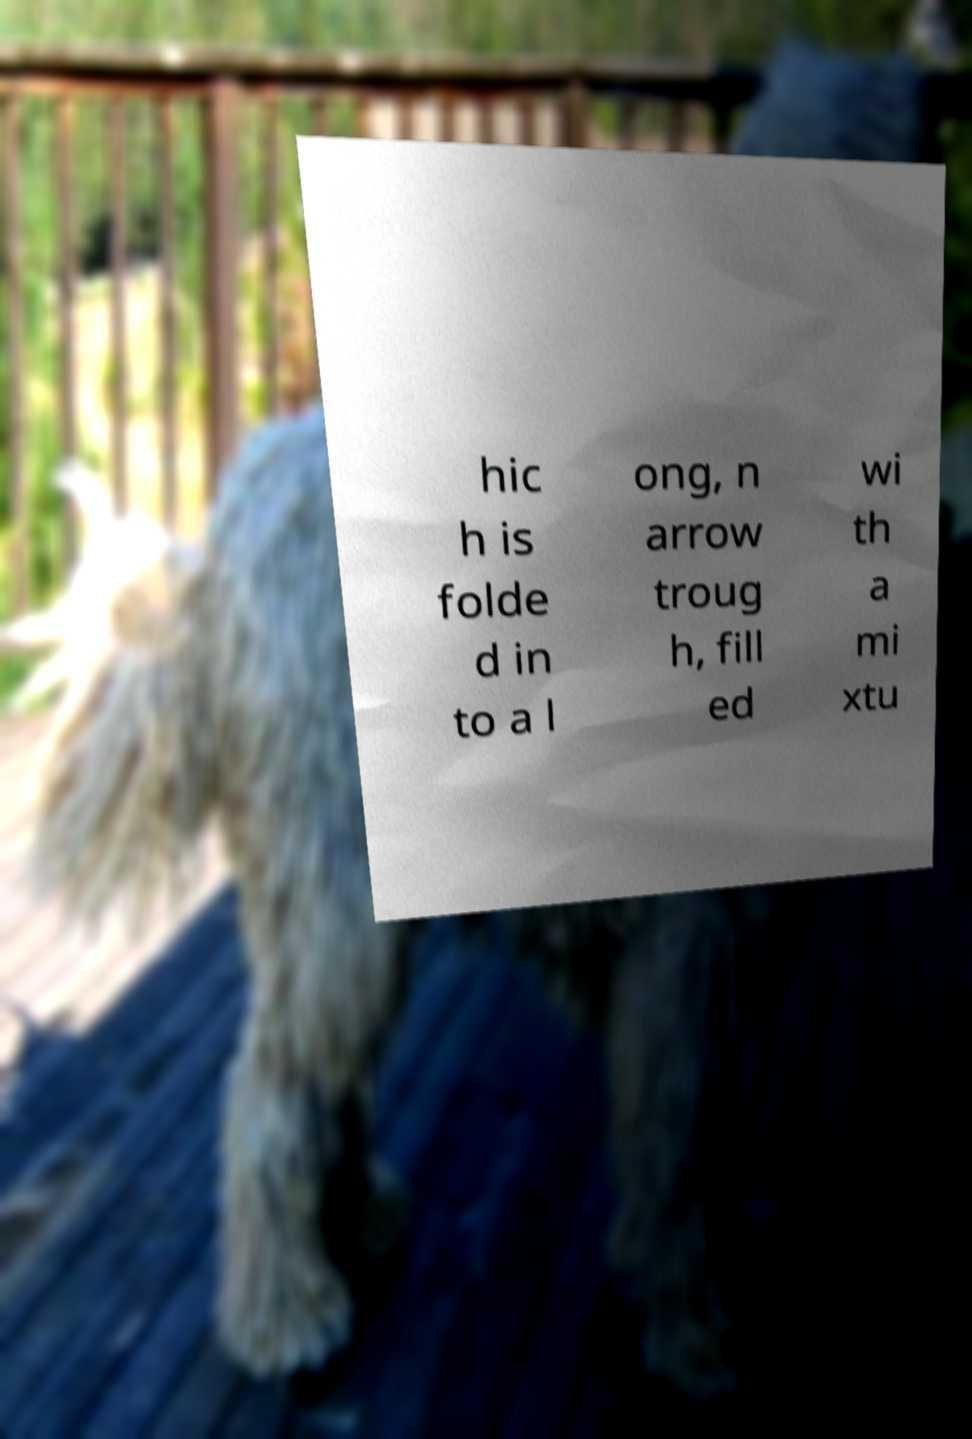I need the written content from this picture converted into text. Can you do that? hic h is folde d in to a l ong, n arrow troug h, fill ed wi th a mi xtu 